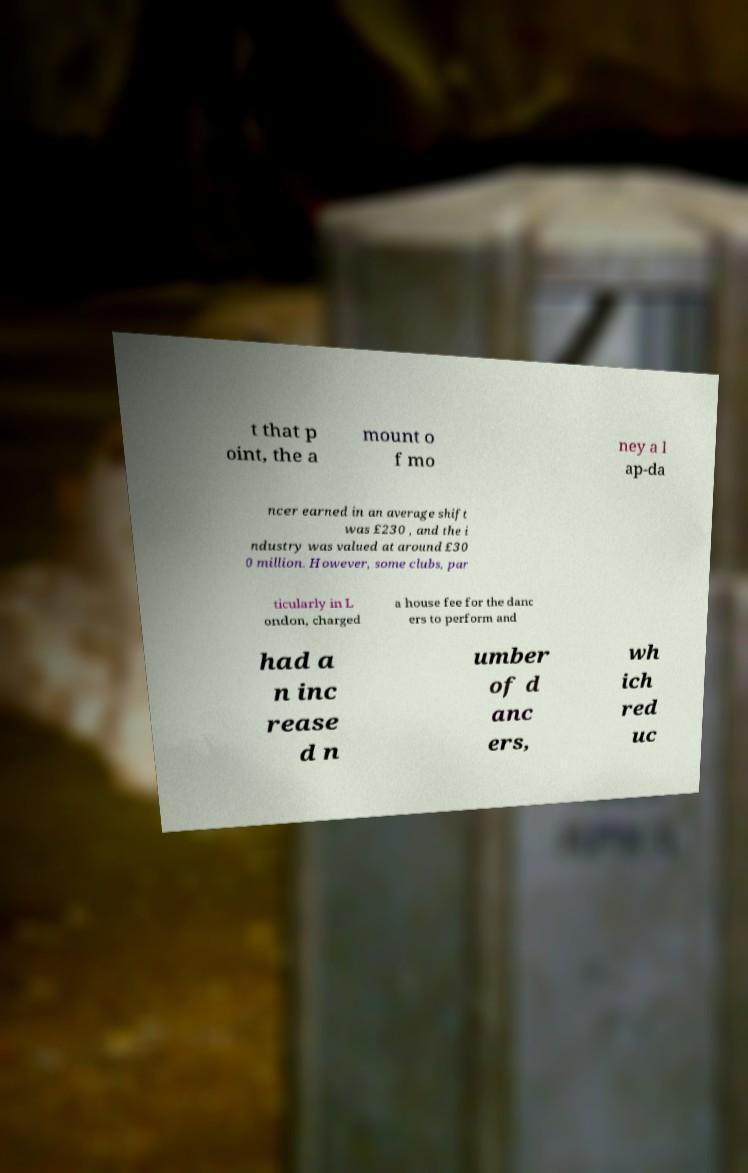Could you extract and type out the text from this image? t that p oint, the a mount o f mo ney a l ap-da ncer earned in an average shift was £230 , and the i ndustry was valued at around £30 0 million. However, some clubs, par ticularly in L ondon, charged a house fee for the danc ers to perform and had a n inc rease d n umber of d anc ers, wh ich red uc 